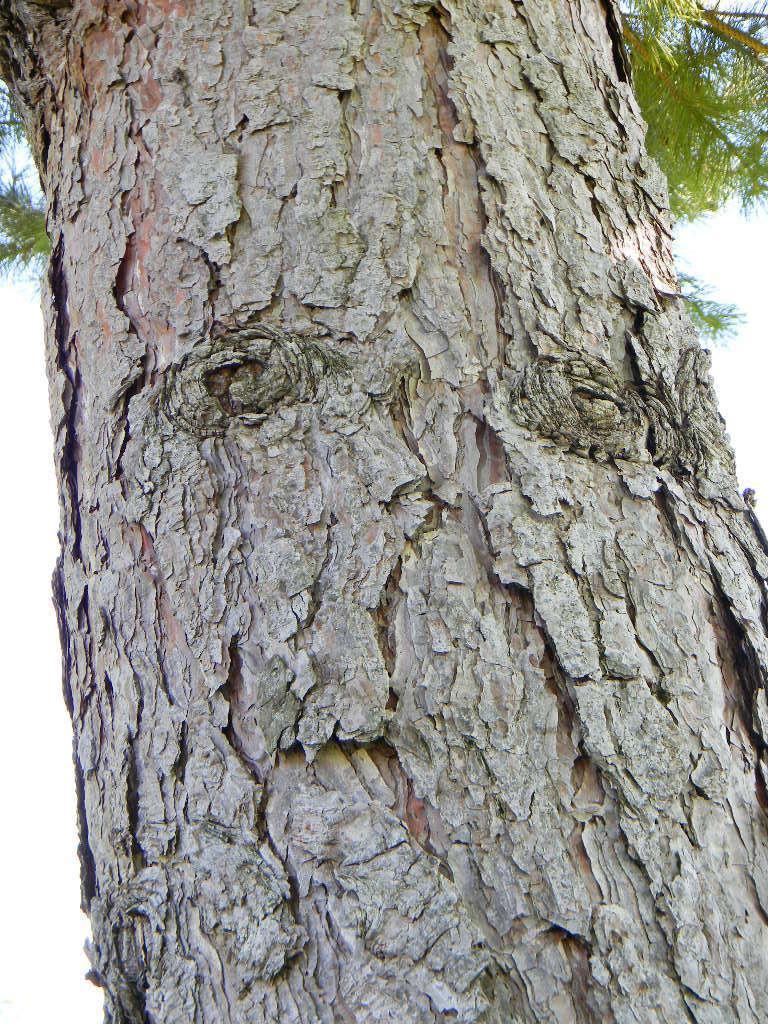Could you give a brief overview of what you see in this image? In the picture we can see a tree branch and some plants on the top of it and besides, we can see some part of the sky. 